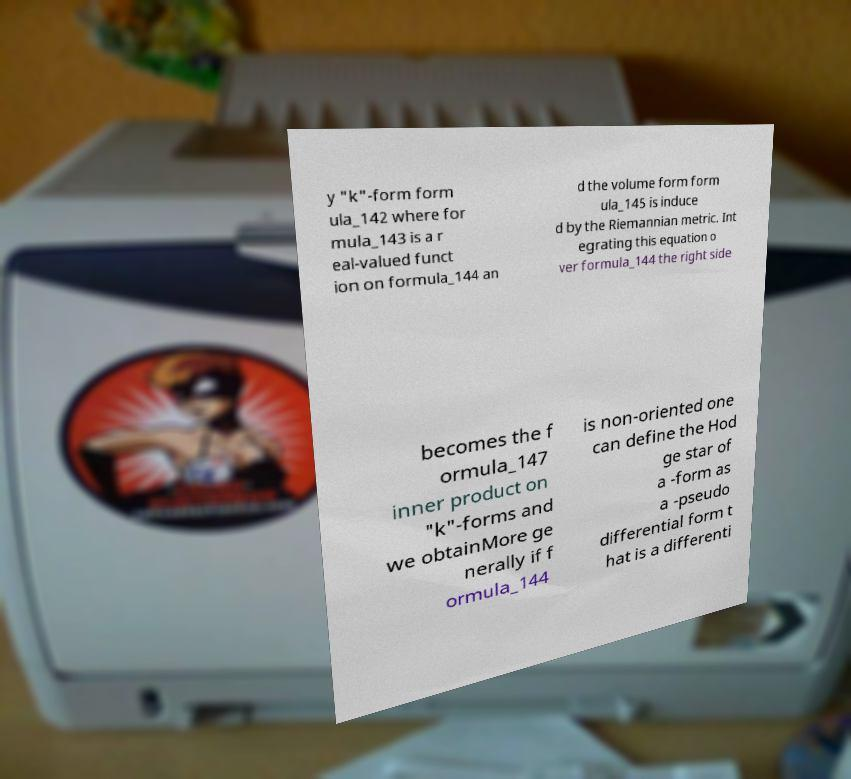Can you read and provide the text displayed in the image?This photo seems to have some interesting text. Can you extract and type it out for me? y "k"-form form ula_142 where for mula_143 is a r eal-valued funct ion on formula_144 an d the volume form form ula_145 is induce d by the Riemannian metric. Int egrating this equation o ver formula_144 the right side becomes the f ormula_147 inner product on "k"-forms and we obtainMore ge nerally if f ormula_144 is non-oriented one can define the Hod ge star of a -form as a -pseudo differential form t hat is a differenti 